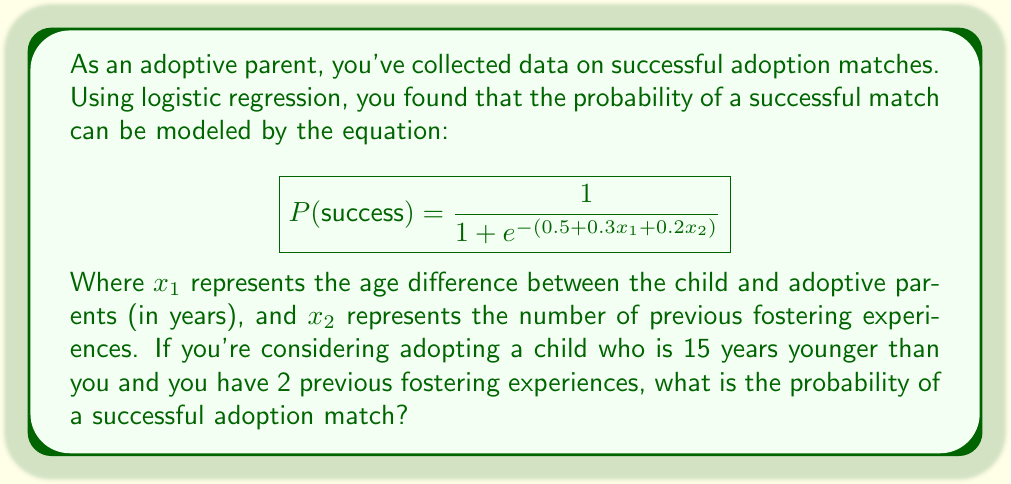What is the answer to this math problem? To solve this problem, we'll follow these steps:

1. Identify the given information:
   - The logistic regression equation is: $$P(success) = \frac{1}{1 + e^{-(0.5 + 0.3x_1 + 0.2x_2)}}$$
   - $x_1$ (age difference) = 15 years
   - $x_2$ (previous fostering experiences) = 2

2. Substitute the values into the equation:
   $$P(success) = \frac{1}{1 + e^{-(0.5 + 0.3(15) + 0.2(2))}}$$

3. Simplify the expression inside the exponential:
   $$P(success) = \frac{1}{1 + e^{-(0.5 + 4.5 + 0.4)}}$$
   $$P(success) = \frac{1}{1 + e^{-5.4}}$$

4. Calculate the value of $e^{-5.4}$:
   $e^{-5.4} \approx 0.00452$

5. Substitute this value back into the equation:
   $$P(success) = \frac{1}{1 + 0.00452}$$

6. Perform the final calculation:
   $$P(success) = \frac{1}{1.00452} \approx 0.9955$$

7. Convert to a percentage:
   0.9955 * 100 = 99.55%
Answer: 99.55% 